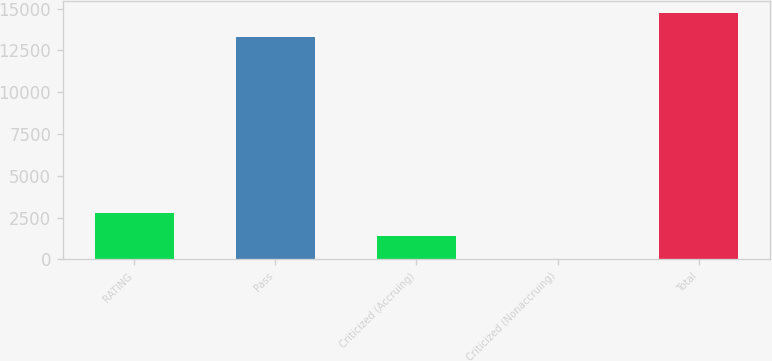Convert chart to OTSL. <chart><loc_0><loc_0><loc_500><loc_500><bar_chart><fcel>RATING<fcel>Pass<fcel>Criticized (Accruing)<fcel>Criticized (Nonaccruing)<fcel>Total<nl><fcel>2792<fcel>13328<fcel>1411<fcel>30<fcel>14709<nl></chart> 